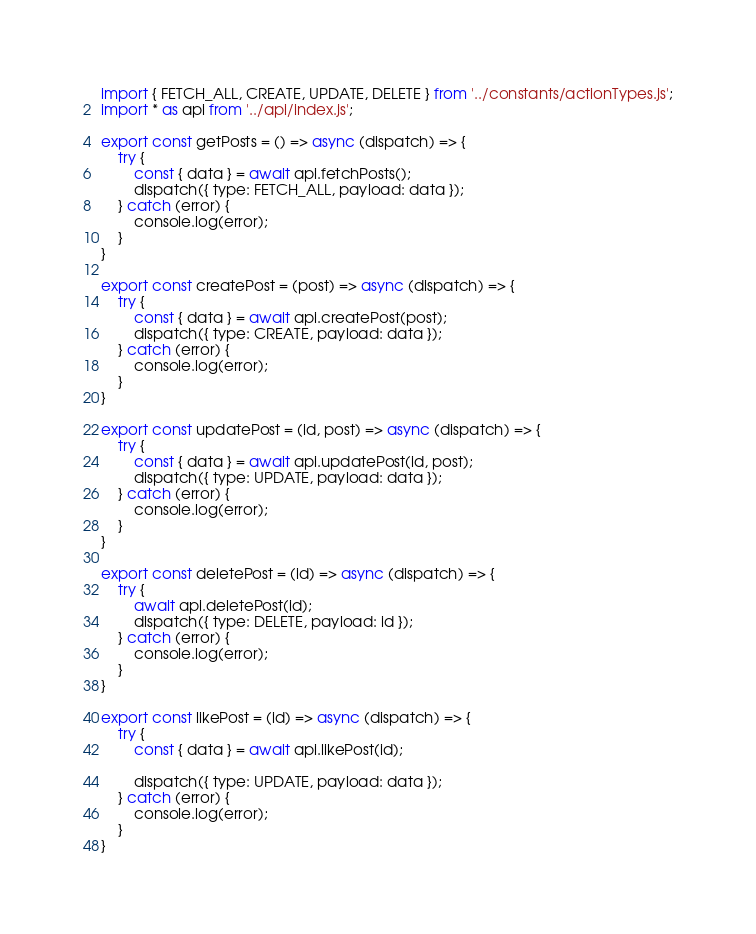Convert code to text. <code><loc_0><loc_0><loc_500><loc_500><_JavaScript_>import { FETCH_ALL, CREATE, UPDATE, DELETE } from '../constants/actionTypes.js';
import * as api from '../api/index.js';

export const getPosts = () => async (dispatch) => {
    try {
        const { data } = await api.fetchPosts();
        dispatch({ type: FETCH_ALL, payload: data });
    } catch (error) {
        console.log(error);
    }
}

export const createPost = (post) => async (dispatch) => {
    try {
        const { data } = await api.createPost(post);
        dispatch({ type: CREATE, payload: data });
    } catch (error) {
        console.log(error);
    }
}

export const updatePost = (id, post) => async (dispatch) => {
    try {
        const { data } = await api.updatePost(id, post);
        dispatch({ type: UPDATE, payload: data });
    } catch (error) {
        console.log(error);
    }
}

export const deletePost = (id) => async (dispatch) => {
    try {
        await api.deletePost(id);
        dispatch({ type: DELETE, payload: id });
    } catch (error) {
        console.log(error);
    }
}

export const likePost = (id) => async (dispatch) => {
    try {
        const { data } = await api.likePost(id);
        
        dispatch({ type: UPDATE, payload: data });
    } catch (error) {
        console.log(error);
    }
}</code> 